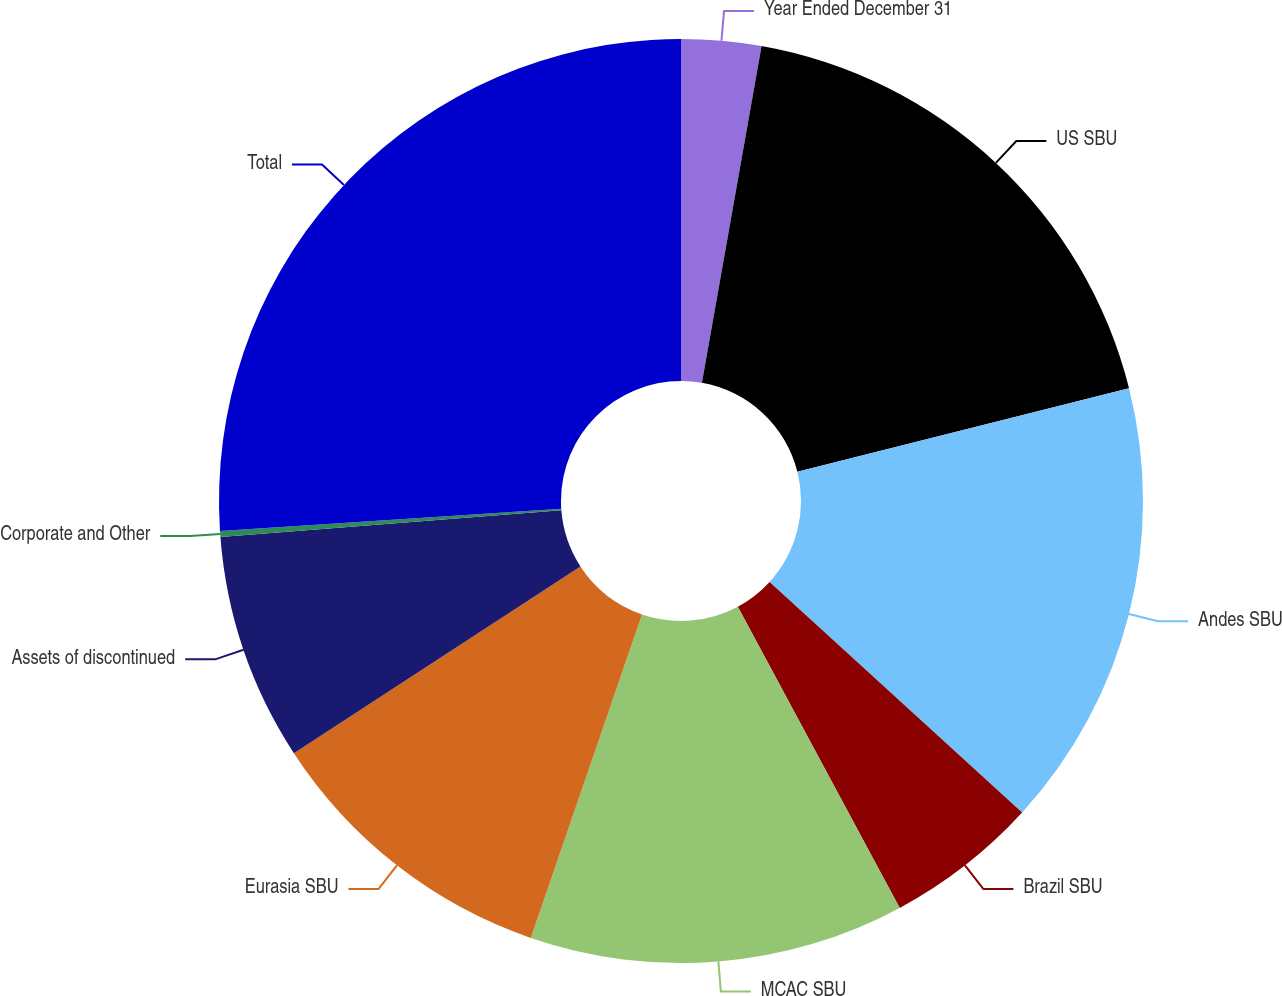<chart> <loc_0><loc_0><loc_500><loc_500><pie_chart><fcel>Year Ended December 31<fcel>US SBU<fcel>Andes SBU<fcel>Brazil SBU<fcel>MCAC SBU<fcel>Eurasia SBU<fcel>Assets of discontinued<fcel>Corporate and Other<fcel>Total<nl><fcel>2.79%<fcel>18.29%<fcel>15.7%<fcel>5.37%<fcel>13.12%<fcel>10.54%<fcel>7.95%<fcel>0.21%<fcel>26.03%<nl></chart> 